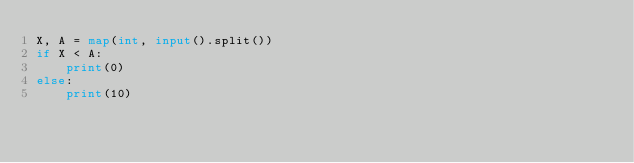<code> <loc_0><loc_0><loc_500><loc_500><_Python_>X, A = map(int, input().split())
if X < A:
    print(0)
else:
    print(10)
</code> 